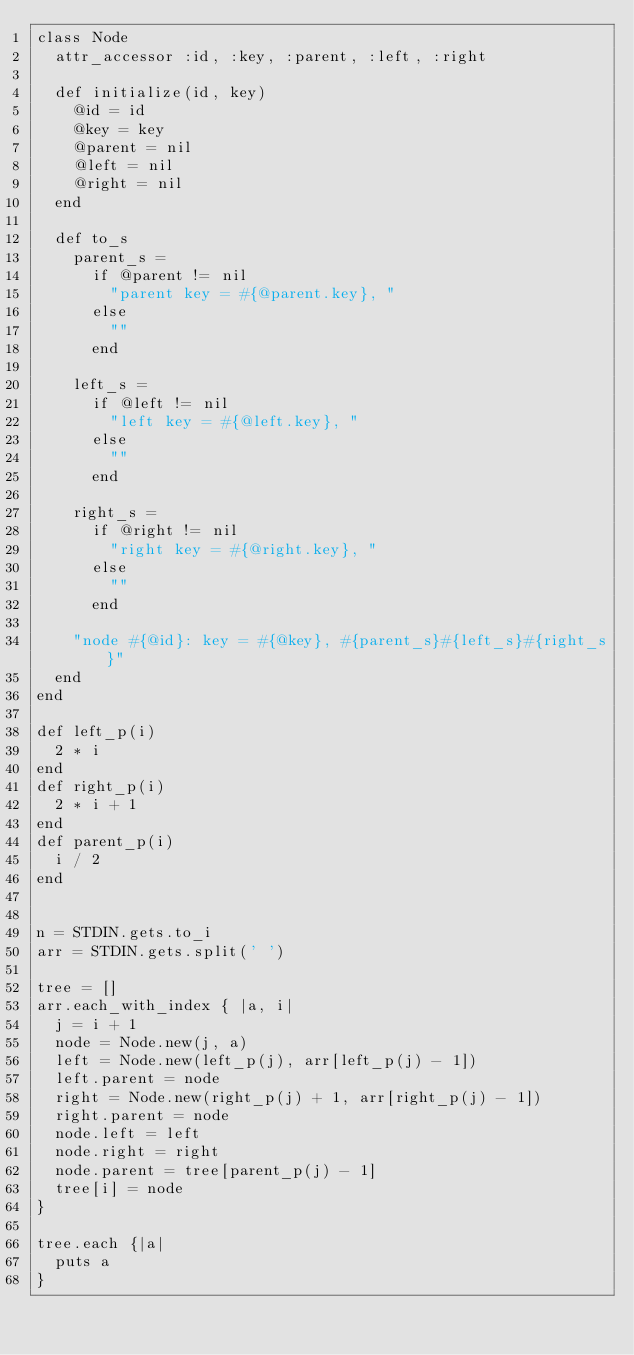Convert code to text. <code><loc_0><loc_0><loc_500><loc_500><_Ruby_>class Node
  attr_accessor :id, :key, :parent, :left, :right

  def initialize(id, key)
    @id = id
    @key = key
    @parent = nil
    @left = nil
    @right = nil
  end

  def to_s
    parent_s =
      if @parent != nil
        "parent key = #{@parent.key}, "
      else
        ""
      end

    left_s =
      if @left != nil
        "left key = #{@left.key}, "
      else
        ""
      end

    right_s =
      if @right != nil
        "right key = #{@right.key}, "
      else
        ""
      end

    "node #{@id}: key = #{@key}, #{parent_s}#{left_s}#{right_s}"
  end
end

def left_p(i)
  2 * i
end
def right_p(i)
  2 * i + 1
end
def parent_p(i)
  i / 2
end


n = STDIN.gets.to_i
arr = STDIN.gets.split(' ')

tree = []
arr.each_with_index { |a, i|
  j = i + 1
  node = Node.new(j, a)
  left = Node.new(left_p(j), arr[left_p(j) - 1])
  left.parent = node
  right = Node.new(right_p(j) + 1, arr[right_p(j) - 1])
  right.parent = node
  node.left = left
  node.right = right
  node.parent = tree[parent_p(j) - 1]
  tree[i] = node
}

tree.each {|a|
  puts a
}</code> 